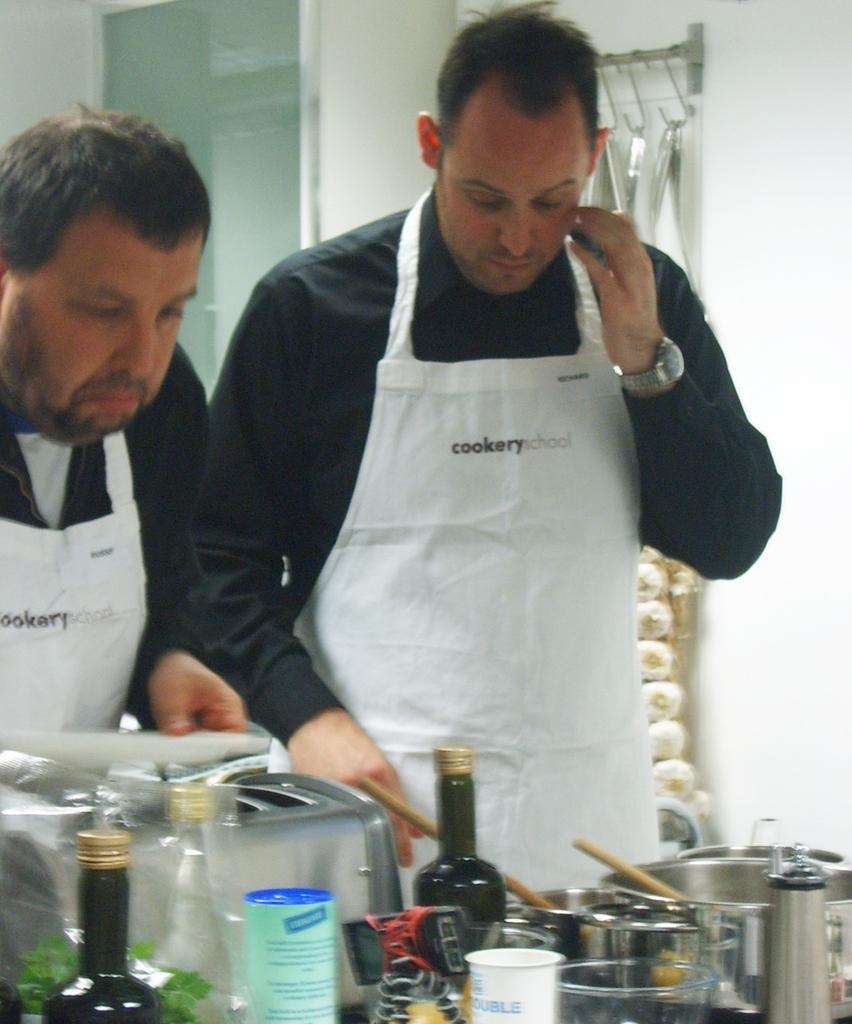How would you summarize this image in a sentence or two? These two persons wore black and white aprons. In-front of this person there is a table, on this table there are bottles, bowl, spatula, cup and machine. 